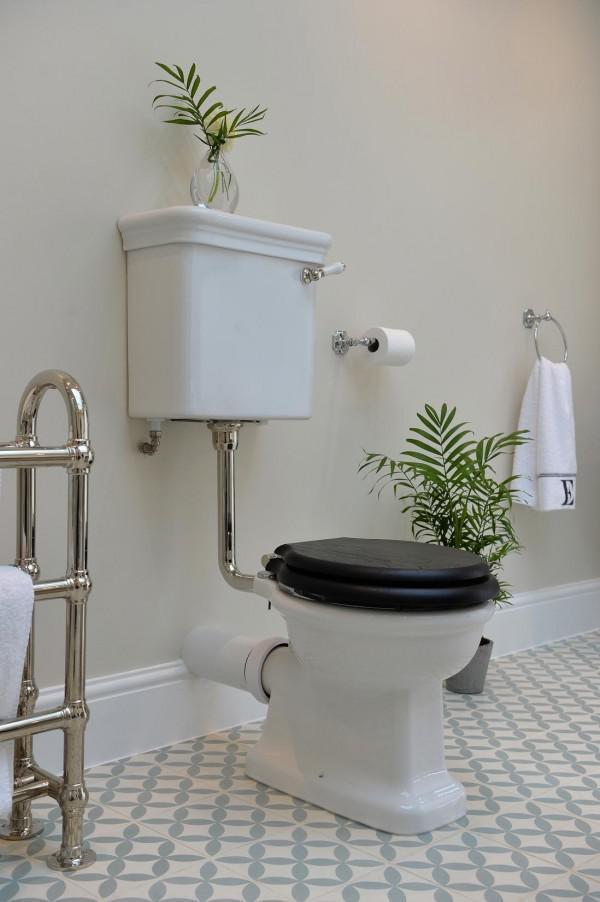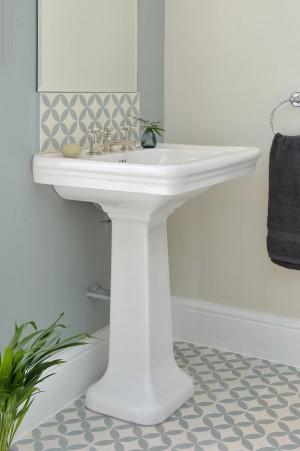The first image is the image on the left, the second image is the image on the right. Examine the images to the left and right. Is the description "A toilet is sitting in a room with a white baseboard in one of the images." accurate? Answer yes or no. Yes. The first image is the image on the left, the second image is the image on the right. Analyze the images presented: Is the assertion "There is a sink on a pillar in a room, with a mirror above it." valid? Answer yes or no. Yes. 